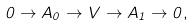<formula> <loc_0><loc_0><loc_500><loc_500>0 \to A _ { 0 } \to V \to A _ { 1 } \to 0 ,</formula> 